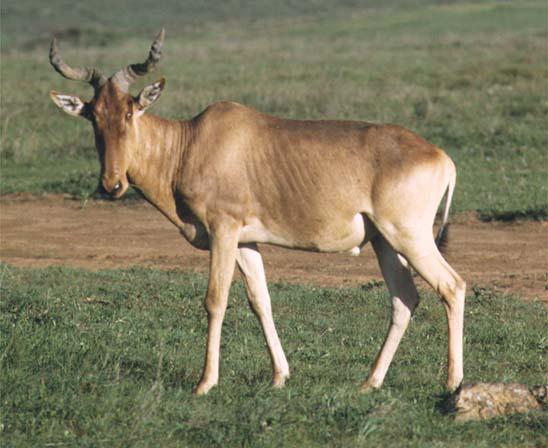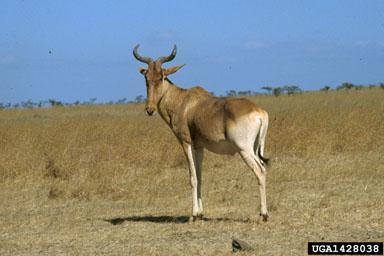The first image is the image on the left, the second image is the image on the right. Analyze the images presented: Is the assertion "There are two different types of animals in one of the pictures." valid? Answer yes or no. No. 